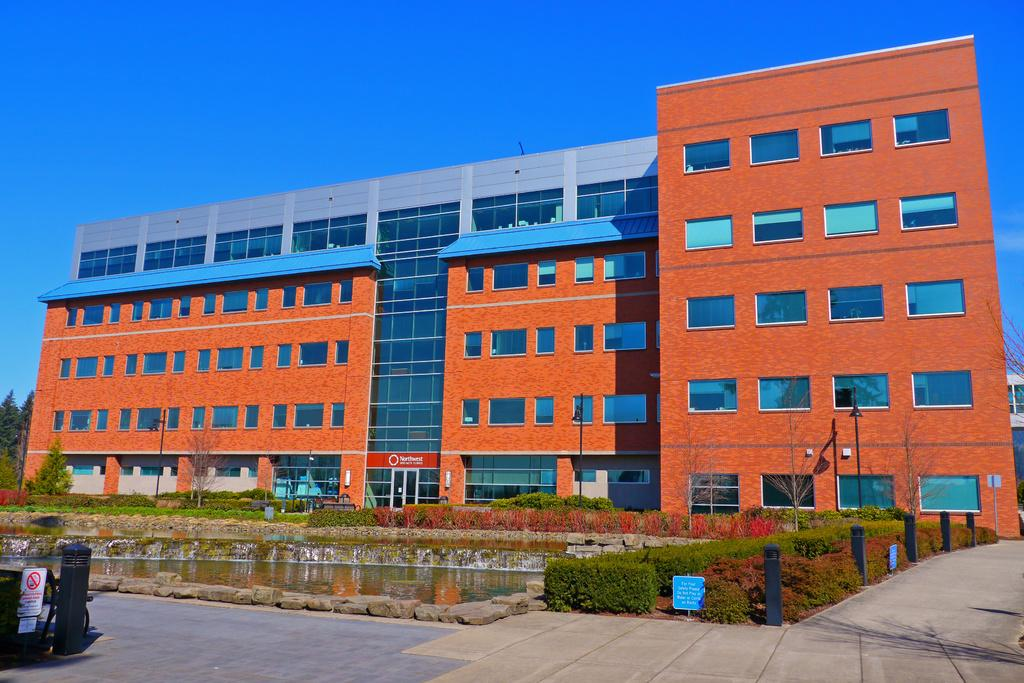What type of path is present in the image? There is a walkway in the image. What natural element can be seen alongside the walkway? Water is visible in the image. What type of vegetation is present in the image? There are plants in the image. What can be seen in the distance in the image? There is a building in the background of the image. What is the condition of the sky in the image? The sky is clear in the image. Can you hear the sound of thunder in the image? There is no sound present in the image, and therefore no thunder can be heard. Are there any jellyfish visible in the water in the image? There are no jellyfish present in the image; only water and plants are visible alongside the walkway. 